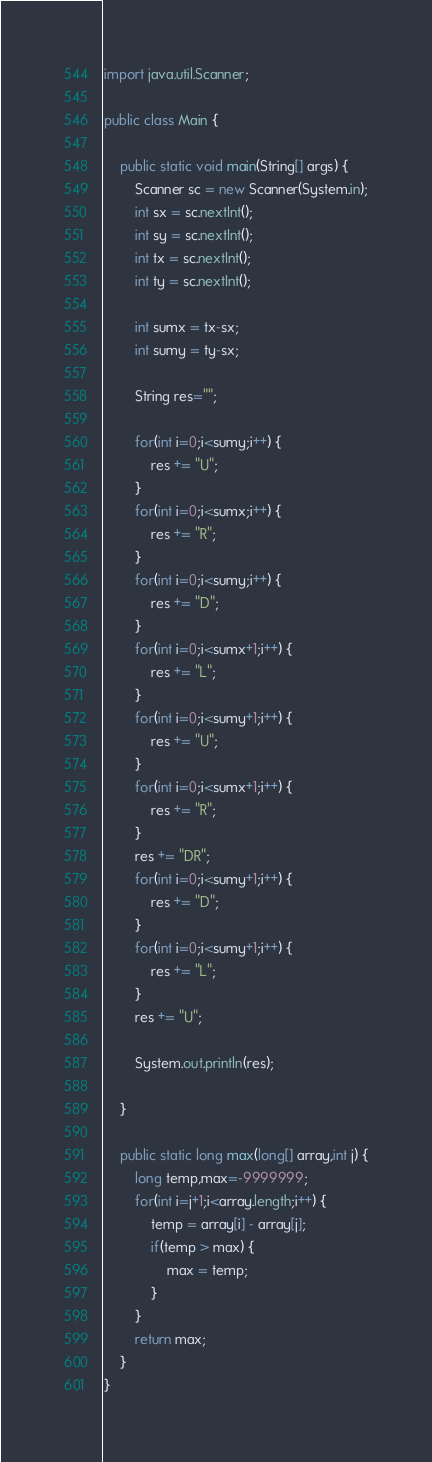Convert code to text. <code><loc_0><loc_0><loc_500><loc_500><_Java_>import java.util.Scanner;

public class Main {

	public static void main(String[] args) {
		Scanner sc = new Scanner(System.in);
		int sx = sc.nextInt();
		int sy = sc.nextInt();
		int tx = sc.nextInt();
		int ty = sc.nextInt();

		int sumx = tx-sx;
		int sumy = ty-sx;

		String res="";

		for(int i=0;i<sumy;i++) {
			res += "U";
		}
		for(int i=0;i<sumx;i++) {
			res += "R";
		}
		for(int i=0;i<sumy;i++) {
			res += "D";
		}
		for(int i=0;i<sumx+1;i++) {
			res += "L";
		}
		for(int i=0;i<sumy+1;i++) {
			res += "U";
		}
		for(int i=0;i<sumx+1;i++) {
			res += "R";
		}
		res += "DR";
		for(int i=0;i<sumy+1;i++) {
			res += "D";
		}
		for(int i=0;i<sumy+1;i++) {
			res += "L";
		}
		res += "U";

		System.out.println(res);

	}

	public static long max(long[] array,int j) {
		long temp,max=-9999999;
		for(int i=j+1;i<array.length;i++) {
			temp = array[i] - array[j];
			if(temp > max) {
				max = temp;
			}
		}
		return max;
	}
}
</code> 